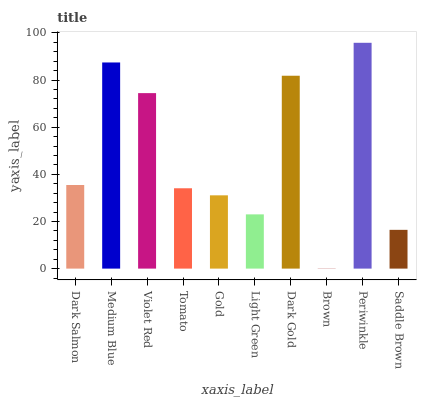Is Brown the minimum?
Answer yes or no. Yes. Is Periwinkle the maximum?
Answer yes or no. Yes. Is Medium Blue the minimum?
Answer yes or no. No. Is Medium Blue the maximum?
Answer yes or no. No. Is Medium Blue greater than Dark Salmon?
Answer yes or no. Yes. Is Dark Salmon less than Medium Blue?
Answer yes or no. Yes. Is Dark Salmon greater than Medium Blue?
Answer yes or no. No. Is Medium Blue less than Dark Salmon?
Answer yes or no. No. Is Dark Salmon the high median?
Answer yes or no. Yes. Is Tomato the low median?
Answer yes or no. Yes. Is Tomato the high median?
Answer yes or no. No. Is Medium Blue the low median?
Answer yes or no. No. 